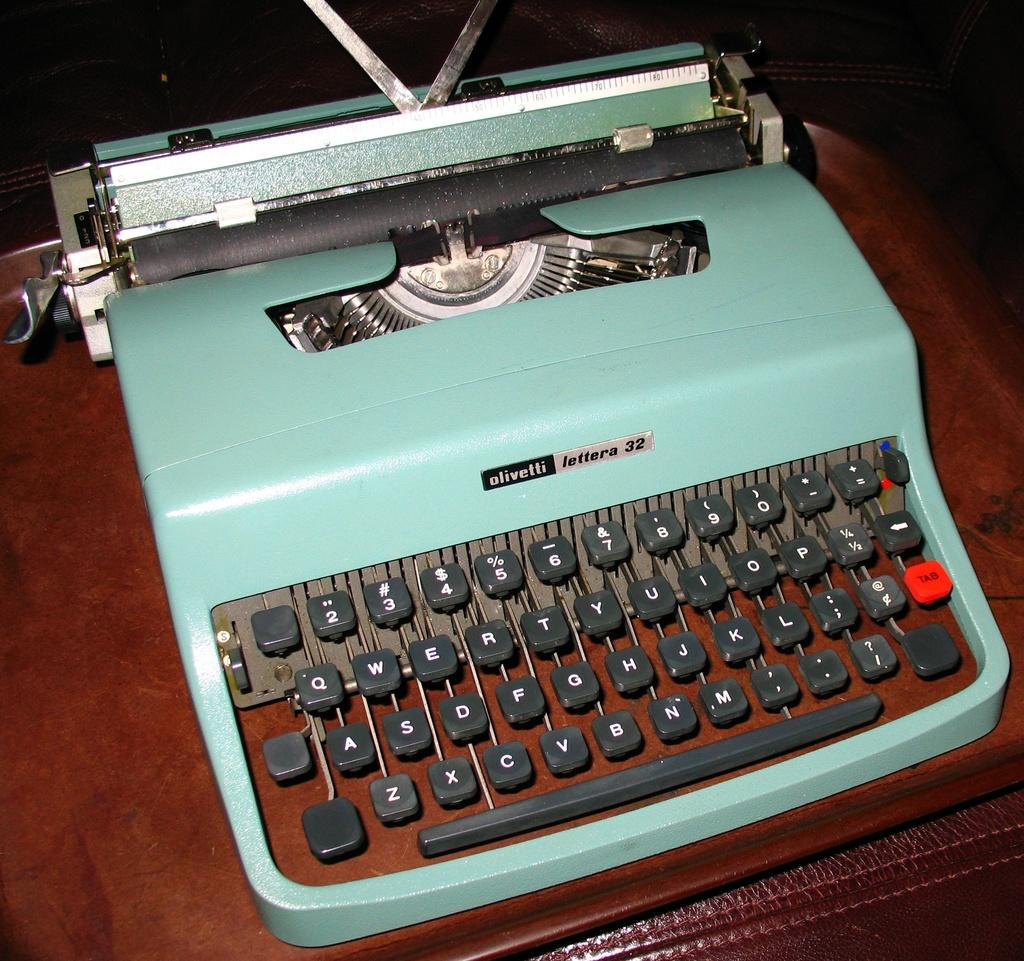What is the main object in the image? There is a typewriter machine in the image. Where is the typewriter machine located? The typewriter machine is on a table. Can you describe the setting in which the image might have been taken? The image might have been taken in a hall. What type of paint is being used on the ship in the image? There is no ship or paint present in the image; it features a typewriter machine on a table. Can you tell me how many books are visible in the library in the image? There is no library present in the image; it features a typewriter machine on a table. 